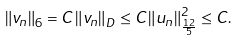<formula> <loc_0><loc_0><loc_500><loc_500>\left \| v _ { n } \right \| _ { 6 } = C \left \| v _ { n } \right \| _ { D } \leq C \left \| u _ { n } \right \| _ { \frac { 1 2 } { 5 } } ^ { 2 } \leq C .</formula> 